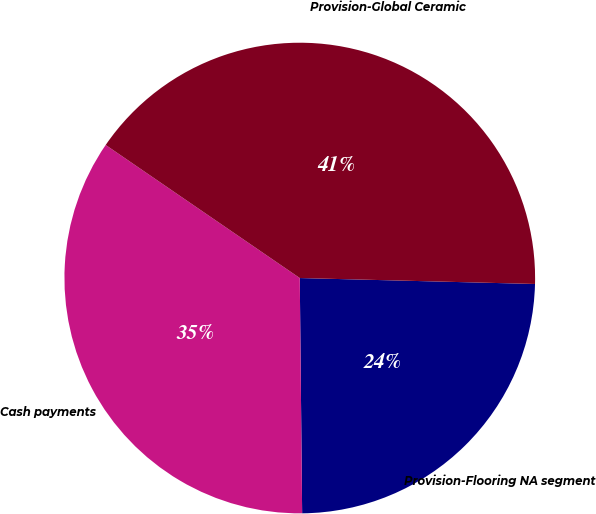Convert chart. <chart><loc_0><loc_0><loc_500><loc_500><pie_chart><fcel>Provision-Flooring NA segment<fcel>Cash payments<fcel>Provision-Global Ceramic<nl><fcel>24.44%<fcel>34.73%<fcel>40.84%<nl></chart> 